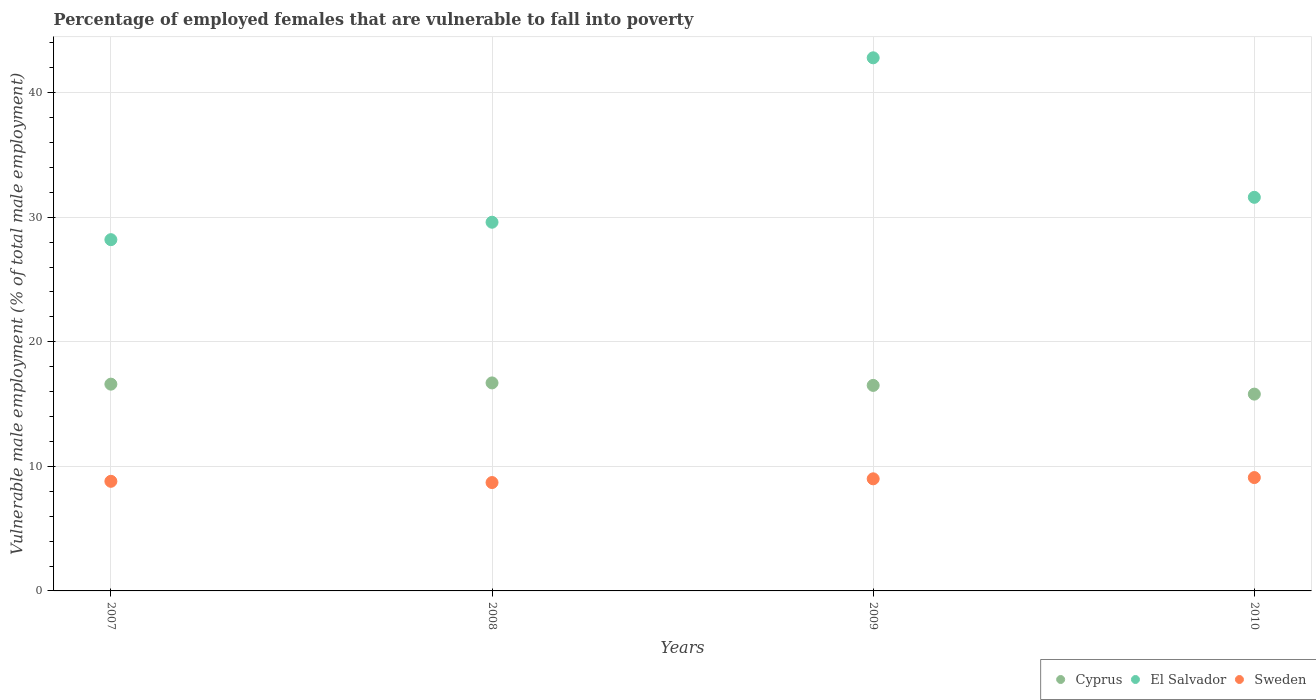What is the percentage of employed females who are vulnerable to fall into poverty in El Salvador in 2008?
Provide a short and direct response. 29.6. Across all years, what is the maximum percentage of employed females who are vulnerable to fall into poverty in Cyprus?
Your answer should be compact. 16.7. Across all years, what is the minimum percentage of employed females who are vulnerable to fall into poverty in Cyprus?
Ensure brevity in your answer.  15.8. What is the total percentage of employed females who are vulnerable to fall into poverty in Cyprus in the graph?
Your response must be concise. 65.6. What is the difference between the percentage of employed females who are vulnerable to fall into poverty in El Salvador in 2008 and that in 2010?
Keep it short and to the point. -2. What is the difference between the percentage of employed females who are vulnerable to fall into poverty in Sweden in 2007 and the percentage of employed females who are vulnerable to fall into poverty in El Salvador in 2009?
Your answer should be very brief. -34. What is the average percentage of employed females who are vulnerable to fall into poverty in Cyprus per year?
Offer a very short reply. 16.4. In the year 2009, what is the difference between the percentage of employed females who are vulnerable to fall into poverty in Cyprus and percentage of employed females who are vulnerable to fall into poverty in El Salvador?
Offer a very short reply. -26.3. What is the ratio of the percentage of employed females who are vulnerable to fall into poverty in Sweden in 2008 to that in 2009?
Offer a terse response. 0.97. Is the percentage of employed females who are vulnerable to fall into poverty in El Salvador in 2009 less than that in 2010?
Offer a terse response. No. Is the difference between the percentage of employed females who are vulnerable to fall into poverty in Cyprus in 2008 and 2009 greater than the difference between the percentage of employed females who are vulnerable to fall into poverty in El Salvador in 2008 and 2009?
Provide a succinct answer. Yes. What is the difference between the highest and the second highest percentage of employed females who are vulnerable to fall into poverty in El Salvador?
Your response must be concise. 11.2. What is the difference between the highest and the lowest percentage of employed females who are vulnerable to fall into poverty in Cyprus?
Give a very brief answer. 0.9. Is the sum of the percentage of employed females who are vulnerable to fall into poverty in Sweden in 2007 and 2010 greater than the maximum percentage of employed females who are vulnerable to fall into poverty in Cyprus across all years?
Ensure brevity in your answer.  Yes. Is the percentage of employed females who are vulnerable to fall into poverty in El Salvador strictly less than the percentage of employed females who are vulnerable to fall into poverty in Sweden over the years?
Offer a very short reply. No. How many years are there in the graph?
Ensure brevity in your answer.  4. What is the difference between two consecutive major ticks on the Y-axis?
Your answer should be very brief. 10. Are the values on the major ticks of Y-axis written in scientific E-notation?
Provide a short and direct response. No. Does the graph contain grids?
Ensure brevity in your answer.  Yes. How many legend labels are there?
Make the answer very short. 3. How are the legend labels stacked?
Offer a very short reply. Horizontal. What is the title of the graph?
Your answer should be compact. Percentage of employed females that are vulnerable to fall into poverty. What is the label or title of the X-axis?
Your answer should be compact. Years. What is the label or title of the Y-axis?
Your response must be concise. Vulnerable male employment (% of total male employment). What is the Vulnerable male employment (% of total male employment) of Cyprus in 2007?
Provide a succinct answer. 16.6. What is the Vulnerable male employment (% of total male employment) in El Salvador in 2007?
Offer a very short reply. 28.2. What is the Vulnerable male employment (% of total male employment) of Sweden in 2007?
Make the answer very short. 8.8. What is the Vulnerable male employment (% of total male employment) in Cyprus in 2008?
Ensure brevity in your answer.  16.7. What is the Vulnerable male employment (% of total male employment) of El Salvador in 2008?
Offer a terse response. 29.6. What is the Vulnerable male employment (% of total male employment) in Sweden in 2008?
Provide a short and direct response. 8.7. What is the Vulnerable male employment (% of total male employment) of Cyprus in 2009?
Keep it short and to the point. 16.5. What is the Vulnerable male employment (% of total male employment) in El Salvador in 2009?
Provide a short and direct response. 42.8. What is the Vulnerable male employment (% of total male employment) of Sweden in 2009?
Your response must be concise. 9. What is the Vulnerable male employment (% of total male employment) of Cyprus in 2010?
Offer a very short reply. 15.8. What is the Vulnerable male employment (% of total male employment) in El Salvador in 2010?
Your answer should be compact. 31.6. What is the Vulnerable male employment (% of total male employment) in Sweden in 2010?
Your answer should be compact. 9.1. Across all years, what is the maximum Vulnerable male employment (% of total male employment) of Cyprus?
Keep it short and to the point. 16.7. Across all years, what is the maximum Vulnerable male employment (% of total male employment) of El Salvador?
Offer a very short reply. 42.8. Across all years, what is the maximum Vulnerable male employment (% of total male employment) in Sweden?
Keep it short and to the point. 9.1. Across all years, what is the minimum Vulnerable male employment (% of total male employment) of Cyprus?
Give a very brief answer. 15.8. Across all years, what is the minimum Vulnerable male employment (% of total male employment) in El Salvador?
Offer a terse response. 28.2. Across all years, what is the minimum Vulnerable male employment (% of total male employment) of Sweden?
Provide a succinct answer. 8.7. What is the total Vulnerable male employment (% of total male employment) of Cyprus in the graph?
Give a very brief answer. 65.6. What is the total Vulnerable male employment (% of total male employment) of El Salvador in the graph?
Offer a terse response. 132.2. What is the total Vulnerable male employment (% of total male employment) in Sweden in the graph?
Provide a short and direct response. 35.6. What is the difference between the Vulnerable male employment (% of total male employment) of El Salvador in 2007 and that in 2009?
Make the answer very short. -14.6. What is the difference between the Vulnerable male employment (% of total male employment) of Sweden in 2007 and that in 2009?
Offer a very short reply. -0.2. What is the difference between the Vulnerable male employment (% of total male employment) of Cyprus in 2007 and that in 2010?
Make the answer very short. 0.8. What is the difference between the Vulnerable male employment (% of total male employment) in El Salvador in 2007 and that in 2010?
Make the answer very short. -3.4. What is the difference between the Vulnerable male employment (% of total male employment) in Cyprus in 2008 and that in 2009?
Keep it short and to the point. 0.2. What is the difference between the Vulnerable male employment (% of total male employment) in Sweden in 2008 and that in 2009?
Your answer should be compact. -0.3. What is the difference between the Vulnerable male employment (% of total male employment) in El Salvador in 2008 and that in 2010?
Your response must be concise. -2. What is the difference between the Vulnerable male employment (% of total male employment) of Sweden in 2008 and that in 2010?
Your answer should be compact. -0.4. What is the difference between the Vulnerable male employment (% of total male employment) in El Salvador in 2009 and that in 2010?
Give a very brief answer. 11.2. What is the difference between the Vulnerable male employment (% of total male employment) in El Salvador in 2007 and the Vulnerable male employment (% of total male employment) in Sweden in 2008?
Provide a succinct answer. 19.5. What is the difference between the Vulnerable male employment (% of total male employment) in Cyprus in 2007 and the Vulnerable male employment (% of total male employment) in El Salvador in 2009?
Your answer should be compact. -26.2. What is the difference between the Vulnerable male employment (% of total male employment) of El Salvador in 2007 and the Vulnerable male employment (% of total male employment) of Sweden in 2009?
Ensure brevity in your answer.  19.2. What is the difference between the Vulnerable male employment (% of total male employment) of Cyprus in 2007 and the Vulnerable male employment (% of total male employment) of El Salvador in 2010?
Provide a succinct answer. -15. What is the difference between the Vulnerable male employment (% of total male employment) of Cyprus in 2007 and the Vulnerable male employment (% of total male employment) of Sweden in 2010?
Give a very brief answer. 7.5. What is the difference between the Vulnerable male employment (% of total male employment) of Cyprus in 2008 and the Vulnerable male employment (% of total male employment) of El Salvador in 2009?
Keep it short and to the point. -26.1. What is the difference between the Vulnerable male employment (% of total male employment) of El Salvador in 2008 and the Vulnerable male employment (% of total male employment) of Sweden in 2009?
Provide a succinct answer. 20.6. What is the difference between the Vulnerable male employment (% of total male employment) of Cyprus in 2008 and the Vulnerable male employment (% of total male employment) of El Salvador in 2010?
Offer a terse response. -14.9. What is the difference between the Vulnerable male employment (% of total male employment) in Cyprus in 2008 and the Vulnerable male employment (% of total male employment) in Sweden in 2010?
Your response must be concise. 7.6. What is the difference between the Vulnerable male employment (% of total male employment) of Cyprus in 2009 and the Vulnerable male employment (% of total male employment) of El Salvador in 2010?
Make the answer very short. -15.1. What is the difference between the Vulnerable male employment (% of total male employment) in Cyprus in 2009 and the Vulnerable male employment (% of total male employment) in Sweden in 2010?
Offer a terse response. 7.4. What is the difference between the Vulnerable male employment (% of total male employment) of El Salvador in 2009 and the Vulnerable male employment (% of total male employment) of Sweden in 2010?
Your answer should be compact. 33.7. What is the average Vulnerable male employment (% of total male employment) of Cyprus per year?
Keep it short and to the point. 16.4. What is the average Vulnerable male employment (% of total male employment) in El Salvador per year?
Provide a succinct answer. 33.05. What is the average Vulnerable male employment (% of total male employment) of Sweden per year?
Your answer should be very brief. 8.9. In the year 2007, what is the difference between the Vulnerable male employment (% of total male employment) in Cyprus and Vulnerable male employment (% of total male employment) in El Salvador?
Offer a very short reply. -11.6. In the year 2007, what is the difference between the Vulnerable male employment (% of total male employment) in Cyprus and Vulnerable male employment (% of total male employment) in Sweden?
Keep it short and to the point. 7.8. In the year 2008, what is the difference between the Vulnerable male employment (% of total male employment) in Cyprus and Vulnerable male employment (% of total male employment) in Sweden?
Give a very brief answer. 8. In the year 2008, what is the difference between the Vulnerable male employment (% of total male employment) of El Salvador and Vulnerable male employment (% of total male employment) of Sweden?
Your answer should be very brief. 20.9. In the year 2009, what is the difference between the Vulnerable male employment (% of total male employment) in Cyprus and Vulnerable male employment (% of total male employment) in El Salvador?
Keep it short and to the point. -26.3. In the year 2009, what is the difference between the Vulnerable male employment (% of total male employment) of Cyprus and Vulnerable male employment (% of total male employment) of Sweden?
Give a very brief answer. 7.5. In the year 2009, what is the difference between the Vulnerable male employment (% of total male employment) in El Salvador and Vulnerable male employment (% of total male employment) in Sweden?
Make the answer very short. 33.8. In the year 2010, what is the difference between the Vulnerable male employment (% of total male employment) of Cyprus and Vulnerable male employment (% of total male employment) of El Salvador?
Ensure brevity in your answer.  -15.8. In the year 2010, what is the difference between the Vulnerable male employment (% of total male employment) of Cyprus and Vulnerable male employment (% of total male employment) of Sweden?
Offer a very short reply. 6.7. In the year 2010, what is the difference between the Vulnerable male employment (% of total male employment) of El Salvador and Vulnerable male employment (% of total male employment) of Sweden?
Keep it short and to the point. 22.5. What is the ratio of the Vulnerable male employment (% of total male employment) in El Salvador in 2007 to that in 2008?
Offer a very short reply. 0.95. What is the ratio of the Vulnerable male employment (% of total male employment) in Sweden in 2007 to that in 2008?
Make the answer very short. 1.01. What is the ratio of the Vulnerable male employment (% of total male employment) in El Salvador in 2007 to that in 2009?
Make the answer very short. 0.66. What is the ratio of the Vulnerable male employment (% of total male employment) of Sweden in 2007 to that in 2009?
Your answer should be compact. 0.98. What is the ratio of the Vulnerable male employment (% of total male employment) in Cyprus in 2007 to that in 2010?
Give a very brief answer. 1.05. What is the ratio of the Vulnerable male employment (% of total male employment) in El Salvador in 2007 to that in 2010?
Offer a very short reply. 0.89. What is the ratio of the Vulnerable male employment (% of total male employment) of Sweden in 2007 to that in 2010?
Provide a succinct answer. 0.97. What is the ratio of the Vulnerable male employment (% of total male employment) in Cyprus in 2008 to that in 2009?
Keep it short and to the point. 1.01. What is the ratio of the Vulnerable male employment (% of total male employment) in El Salvador in 2008 to that in 2009?
Offer a very short reply. 0.69. What is the ratio of the Vulnerable male employment (% of total male employment) of Sweden in 2008 to that in 2009?
Your answer should be compact. 0.97. What is the ratio of the Vulnerable male employment (% of total male employment) of Cyprus in 2008 to that in 2010?
Ensure brevity in your answer.  1.06. What is the ratio of the Vulnerable male employment (% of total male employment) of El Salvador in 2008 to that in 2010?
Ensure brevity in your answer.  0.94. What is the ratio of the Vulnerable male employment (% of total male employment) in Sweden in 2008 to that in 2010?
Ensure brevity in your answer.  0.96. What is the ratio of the Vulnerable male employment (% of total male employment) of Cyprus in 2009 to that in 2010?
Provide a short and direct response. 1.04. What is the ratio of the Vulnerable male employment (% of total male employment) of El Salvador in 2009 to that in 2010?
Offer a terse response. 1.35. What is the ratio of the Vulnerable male employment (% of total male employment) of Sweden in 2009 to that in 2010?
Your response must be concise. 0.99. What is the difference between the highest and the second highest Vulnerable male employment (% of total male employment) of Cyprus?
Make the answer very short. 0.1. What is the difference between the highest and the lowest Vulnerable male employment (% of total male employment) of Cyprus?
Keep it short and to the point. 0.9. What is the difference between the highest and the lowest Vulnerable male employment (% of total male employment) of El Salvador?
Provide a succinct answer. 14.6. 